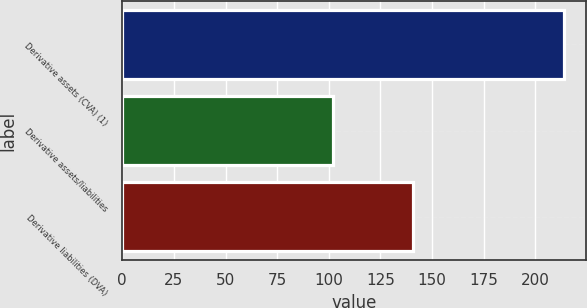<chart> <loc_0><loc_0><loc_500><loc_500><bar_chart><fcel>Derivative assets (CVA) (1)<fcel>Derivative assets/liabilities<fcel>Derivative liabilities (DVA)<nl><fcel>214<fcel>102<fcel>141<nl></chart> 